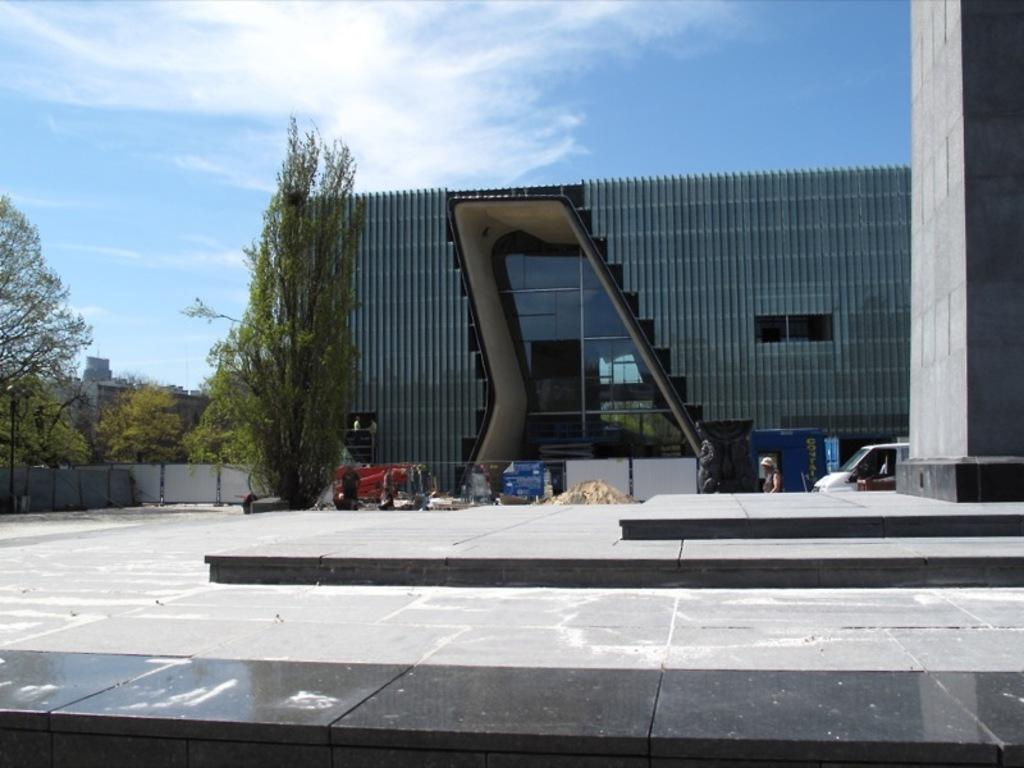What type of vegetation is on the left side of the image? There are trees on the left side of the image. What kind of building is in the middle of the image? There is a building with glass in the middle of the image. What is the condition of the sky in the image? The sky is cloudy at the top of the image. What color is the copper birthmark on the building in the image? There is no copper birthmark present on the building in the image. How does the building turn around in the image? The building does not turn around in the image; it is stationary. 